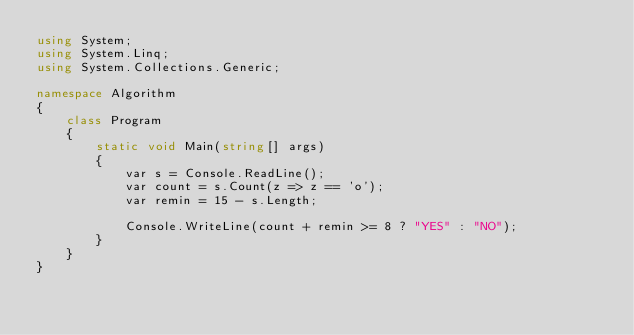Convert code to text. <code><loc_0><loc_0><loc_500><loc_500><_C#_>using System;
using System.Linq;
using System.Collections.Generic;

namespace Algorithm
{
    class Program
    {
        static void Main(string[] args)
        {
            var s = Console.ReadLine();
            var count = s.Count(z => z == 'o');
            var remin = 15 - s.Length;

            Console.WriteLine(count + remin >= 8 ? "YES" : "NO");
        }
    }
}
</code> 